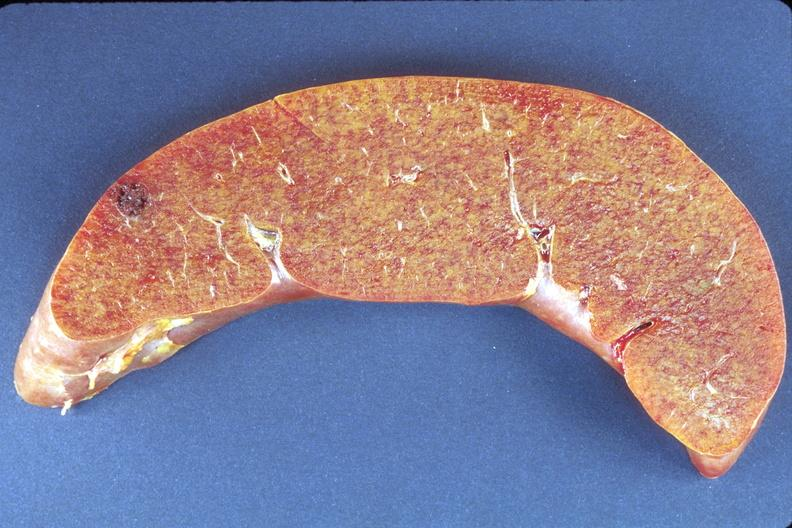s hepatobiliary present?
Answer the question using a single word or phrase. Yes 